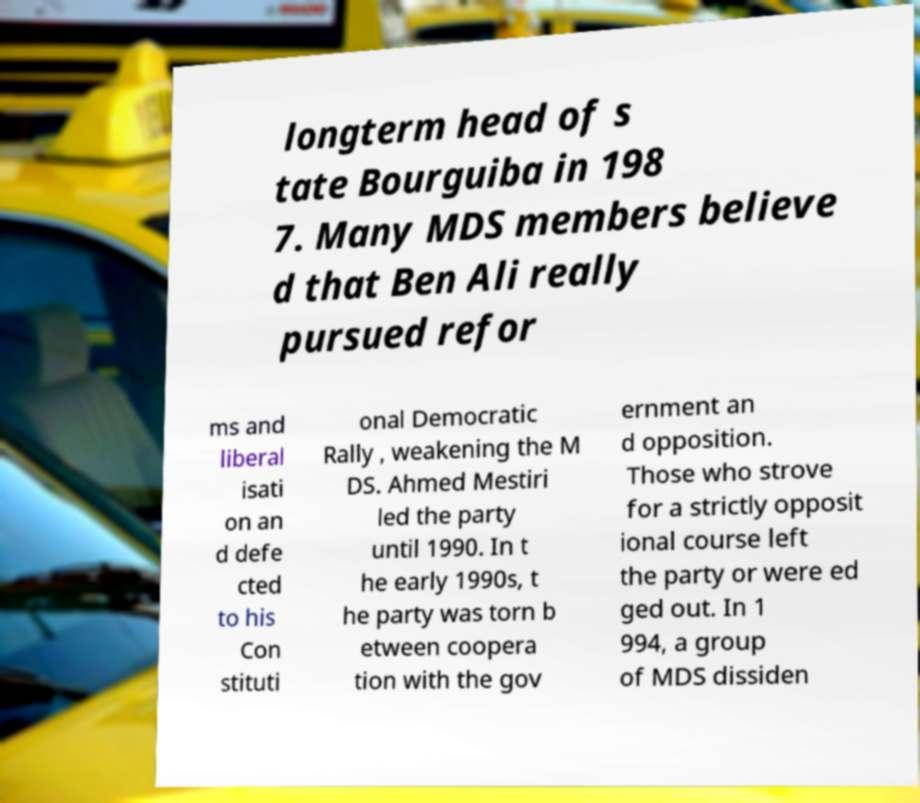Please read and relay the text visible in this image. What does it say? longterm head of s tate Bourguiba in 198 7. Many MDS members believe d that Ben Ali really pursued refor ms and liberal isati on an d defe cted to his Con stituti onal Democratic Rally , weakening the M DS. Ahmed Mestiri led the party until 1990. In t he early 1990s, t he party was torn b etween coopera tion with the gov ernment an d opposition. Those who strove for a strictly opposit ional course left the party or were ed ged out. In 1 994, a group of MDS dissiden 